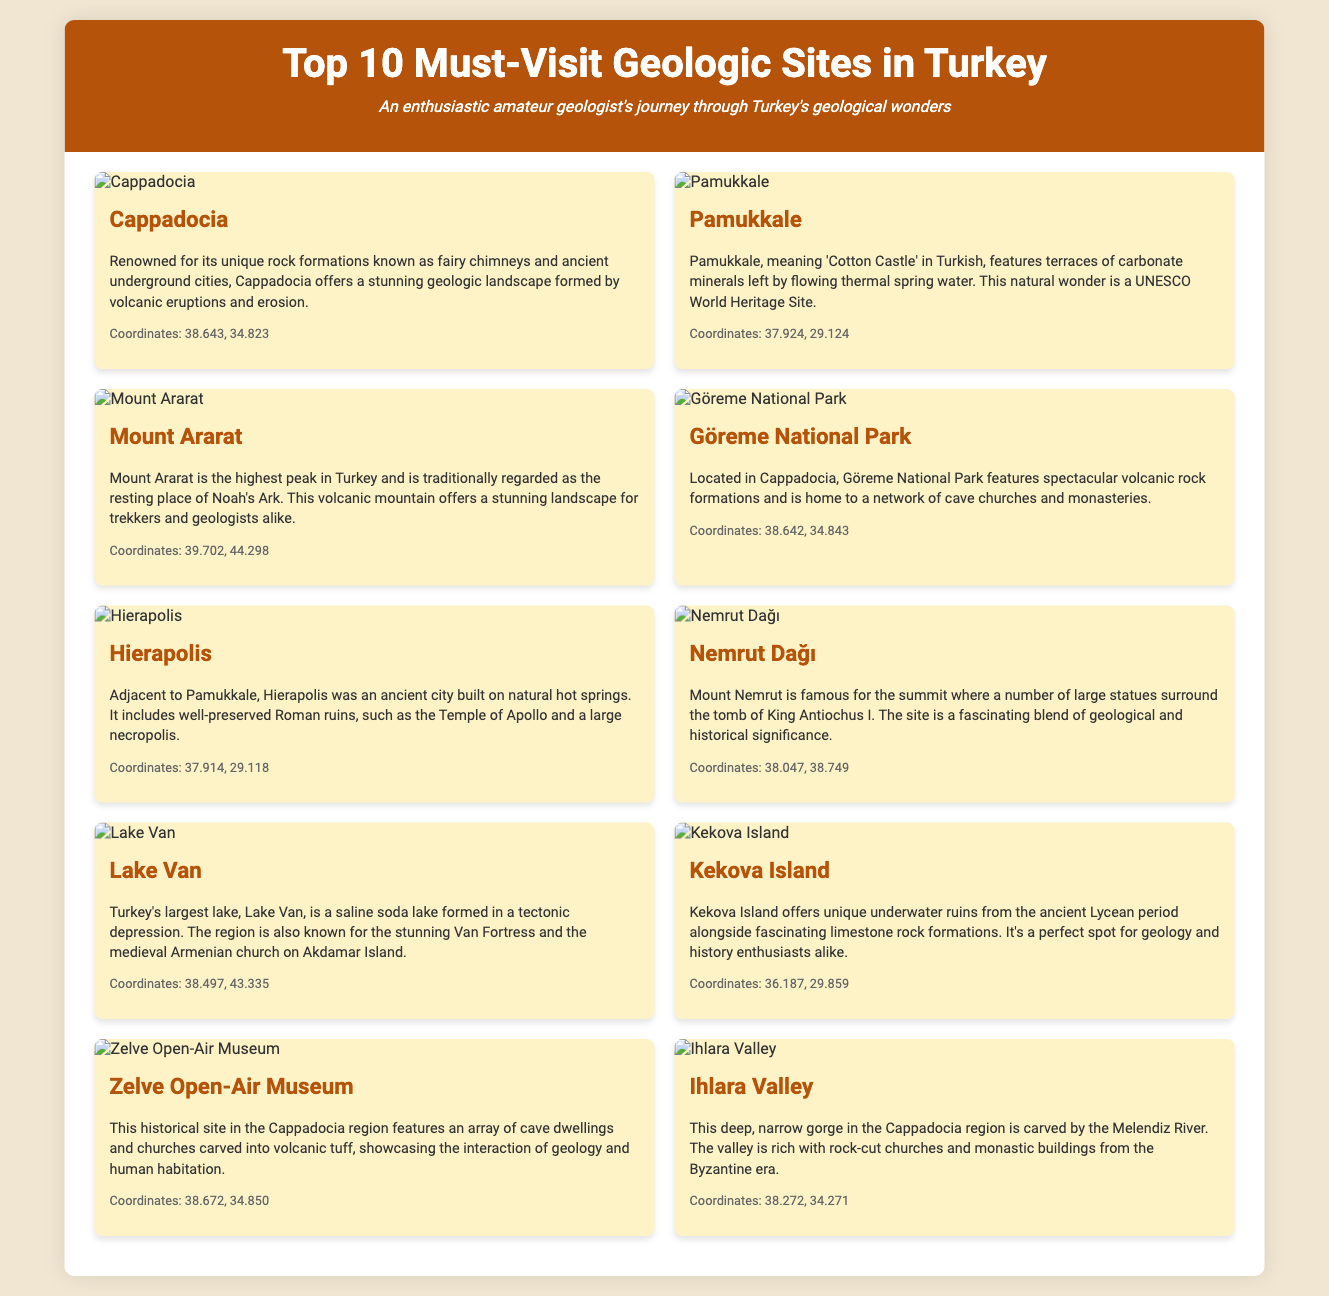What is the geographical feature of Cappadocia? Cappadocia is known for its unique rock formations known as fairy chimneys.
Answer: fairy chimneys What does the name Pamukkale mean in Turkish? Pamukkale means 'Cotton Castle' in Turkish.
Answer: Cotton Castle What is the highest peak in Turkey? Mount Ararat is the highest peak in Turkey.
Answer: Mount Ararat What natural feature is found in Göreme National Park? Göreme National Park features spectacular volcanic rock formations.
Answer: volcanic rock formations What type of lake is Lake Van? Lake Van is a saline soda lake.
Answer: saline soda lake What is significant about the ruins found on Kekova Island? Kekova Island offers unique underwater ruins from the ancient Lycean period.
Answer: underwater ruins How is Ihlara Valley primarily formed? Ihlara Valley is carved by the Melendiz River.
Answer: Melendiz River Which ancient city's ruins are next to Pamukkale? Hierapolis is adjacent to Pamukkale.
Answer: Hierapolis What human-made structures are found in Zelve Open-Air Museum? Zelve Open-Air Museum features cave dwellings and churches carved into volcanic tuff.
Answer: cave dwellings and churches Which historical region includes well-preserved Roman ruins? Hierapolis includes well-preserved Roman ruins.
Answer: Hierapolis 